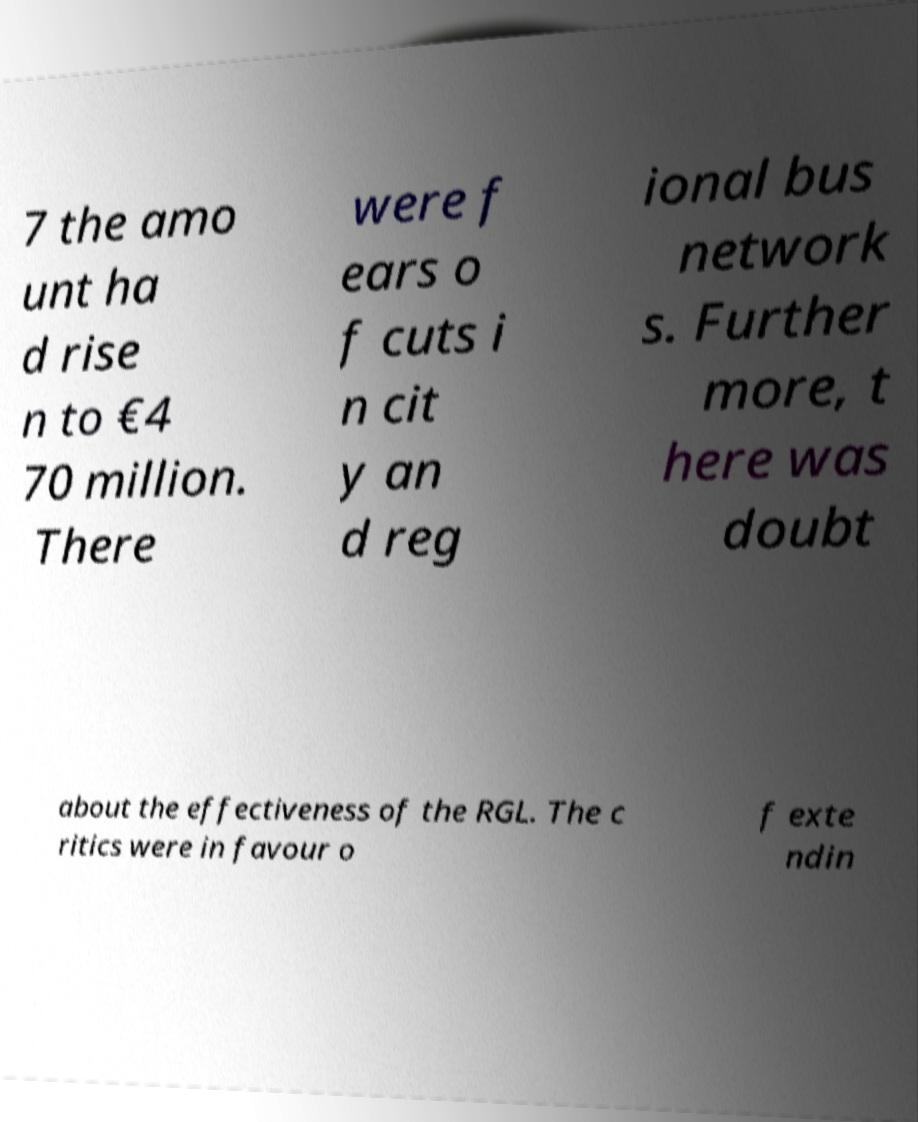For documentation purposes, I need the text within this image transcribed. Could you provide that? 7 the amo unt ha d rise n to €4 70 million. There were f ears o f cuts i n cit y an d reg ional bus network s. Further more, t here was doubt about the effectiveness of the RGL. The c ritics were in favour o f exte ndin 